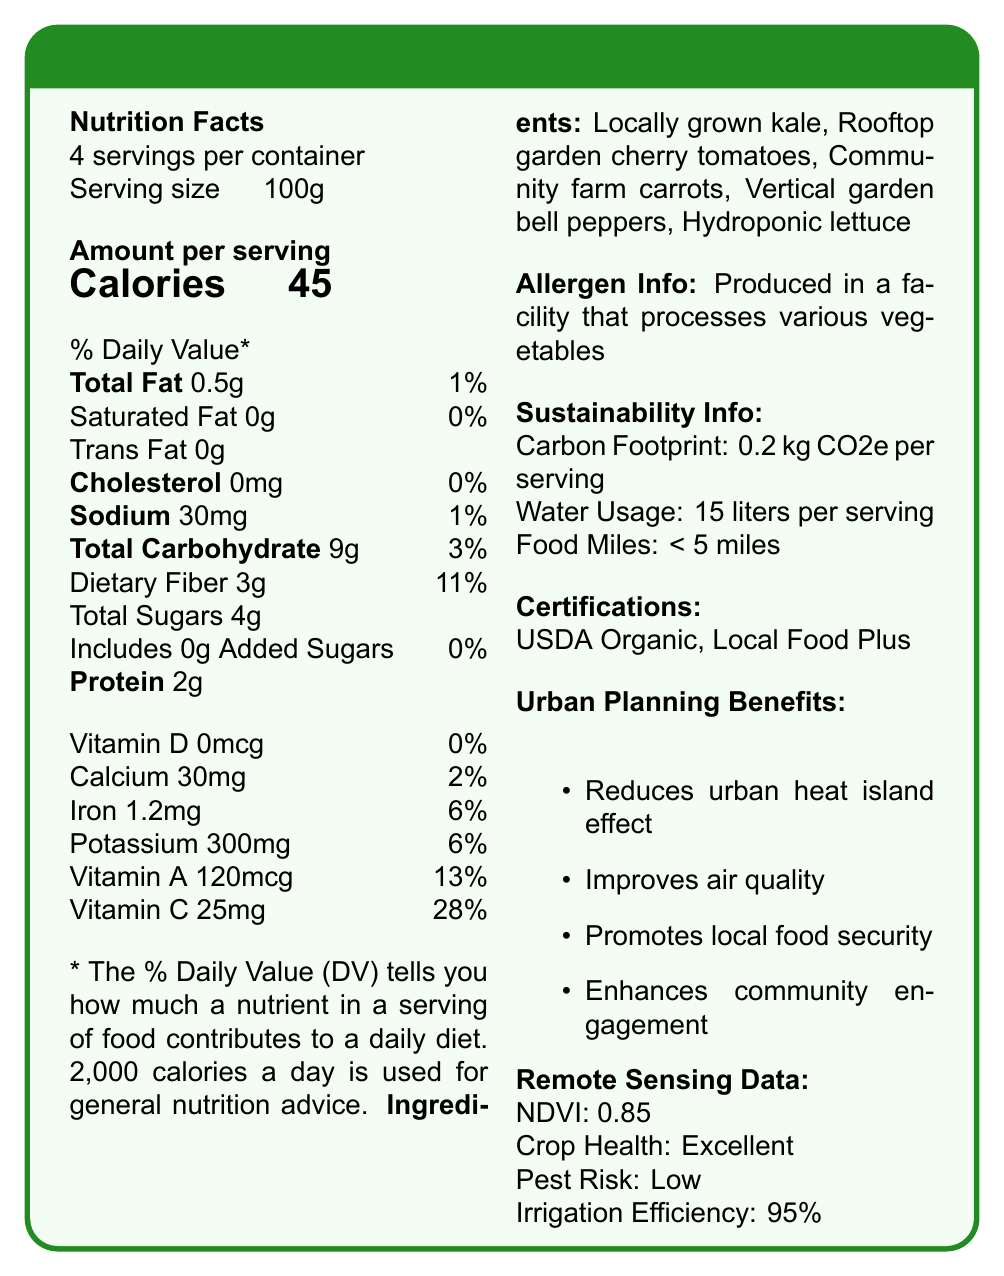What is the serving size for the Urban Harvest Veggie Blend? The serving size is explicitly stated as 100g.
Answer: 100g How many servings are there per container? The document mentions that the blend contains 4 servings per container.
Answer: 4 servings How many calories are there per serving? The document states that there are 45 calories per serving.
Answer: 45 calories What is the total fat content per serving in grams? The total fat per serving is listed as 0.5g.
Answer: 0.5g How many grams of dietary fiber are in each serving? The document shows that each serving has 3g of dietary fiber.
Answer: 3g Which ingredient is NOT listed in the Urban Harvest Veggie Blend? A. Locally grown kale B. Rooftop garden cherry tomatoes C. Store-bought cucumbers D. Vertical garden bell peppers Store-bought cucumbers are not mentioned in the list of ingredients.
Answer: C. Store-bought cucumbers What are the food miles associated with the Urban Harvest Veggie Blend? A. < 2 miles B. < 3 miles C. < 4 miles D. < 5 miles The food miles are stated to be less than 5 miles.
Answer: D. < 5 miles Is the Urban Harvest Veggie Blend certified as USDA Organic? The document lists USDA Organic among its certifications.
Answer: Yes Does each serving of the Urban Harvest Veggie Blend contribute 0% daily value of Vitamin D? The document states that there is 0mcg of Vitamin D per serving, which is 0% of the daily value.
Answer: Yes Summarize the main idea of the Urban Harvest Veggie Blend's nutritional label and its additional benefits. The summary captures the nutritional data, ingredient sourcing, sustainability attributes, and urban planning benefits, providing a comprehensive view of the product's characteristics and advantages.
Answer: The Urban Harvest Veggie Blend provides detailed nutritional information per 100g serving, highlighting its low calorie, fat, and sodium content and rich dietary fiber. It includes locally sourced ingredients like kale and tomatoes and has sustainability benefits such as low carbon footprint and local sourcing. The product contributes positively to urban planning by reducing the urban heat island effect, improving air quality, and promoting local food security. What percentage of the daily value for Vitamin C does each serving provide? The document indicates that each serving provides 25mg of Vitamin C, which is 28% of the daily value.
Answer: 28% What is the iron content per serving? The document states that there is 1.2mg of iron per serving.
Answer: 1.2mg Identify one of the urban planning benefits mentioned in the document. One of the benefits listed in the document is that the Urban Harvest Veggie Blend helps reduce the urban heat island effect.
Answer: Reduces urban heat island effect Does the Urban Harvest Veggie Blend contain any trans fats? The document states explicitly that the blend contains 0g of trans fats.
Answer: No What is the amount of added sugars in each serving? The document shows that there are 0g of added sugars per serving.
Answer: 0g What is the NDVI value mentioned in the remote sensing data? The NDVI value is 0.85, indicating excellent vegetation health.
Answer: 0.85 Can you determine the exact location of the rooftop garden where the cherry tomatoes are grown? The document mentions the rooftop garden but does not provide the exact location.
Answer: Not enough information How much water is used per serving according to the sustainability information? The document states that 15 liters of water are used per serving.
Answer: 15 liters 